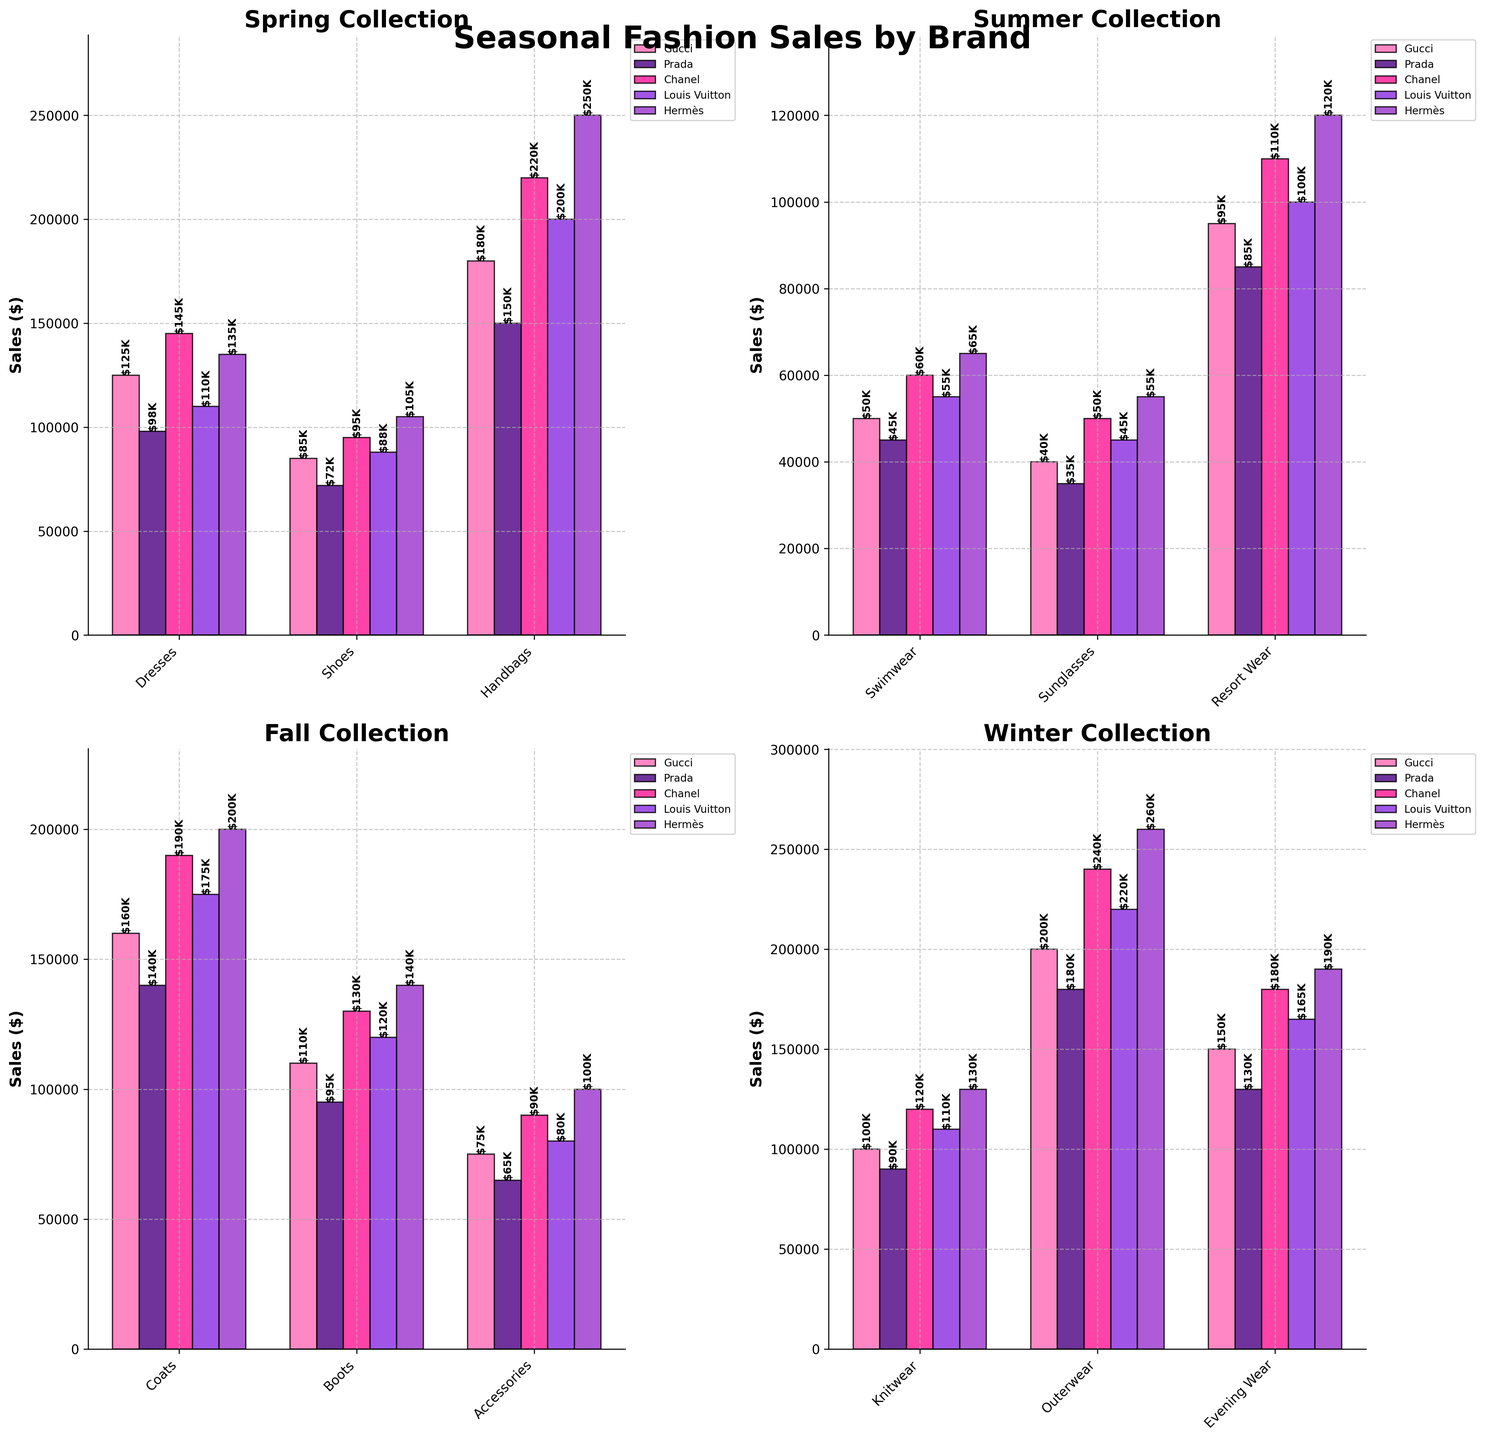Which season has the highest sales for Louis Vuitton handbags? To find the highest sales for Louis Vuitton handbags, we look at the "Handbags" category for each season. Spring has $200,000 for Louis Vuitton handbags, which is the highest among the seasons.
Answer: Spring What's the total sales of Hermès across all categories in the Fall season? To find the total sales of Hermès in Fall, we sum up the sales in the Fall season for each category: Coats ($200,000) + Boots ($140,000) + Accessories ($100,000) = $440,000.
Answer: $440,000 Which brand had the lowest sales in the Summer's Sunglasses category? To determine the lowest sales, we compare the sales values of Gucci ($40,000), Prada ($35,000), Chanel ($50,000), Louis Vuitton ($45,000), Hermès ($55,000) for the Sunglasses category in Summer. Prada has the lowest sales.
Answer: Prada What is the average sales of Dresses in Spring across all brands? To calculate the average, sum the sales for Dresses in Spring for all brands and divide by the number of brands: ($125,000 + $98,000 + $145,000 + $110,000 + $135,000) / 5 = $613,000 / 5 = $122,600.
Answer: $122,600 How do sales of Chanel Swimwear in Summer compare to Louis Vuitton Swimwear in the same season? Check the sales value for Chanel Swimwear ($60,000) and Louis Vuitton Swimwear ($55,000) for the Summer season, and compare them directly. Chanel has higher sales than Louis Vuitton.
Answer: Chanel is higher Which season had the highest total sales for all categories combined? Calculate the total sales for all categories in each season by summing up the sales figures for each brand within a season, and then compare the totals.
Answer: Winter 